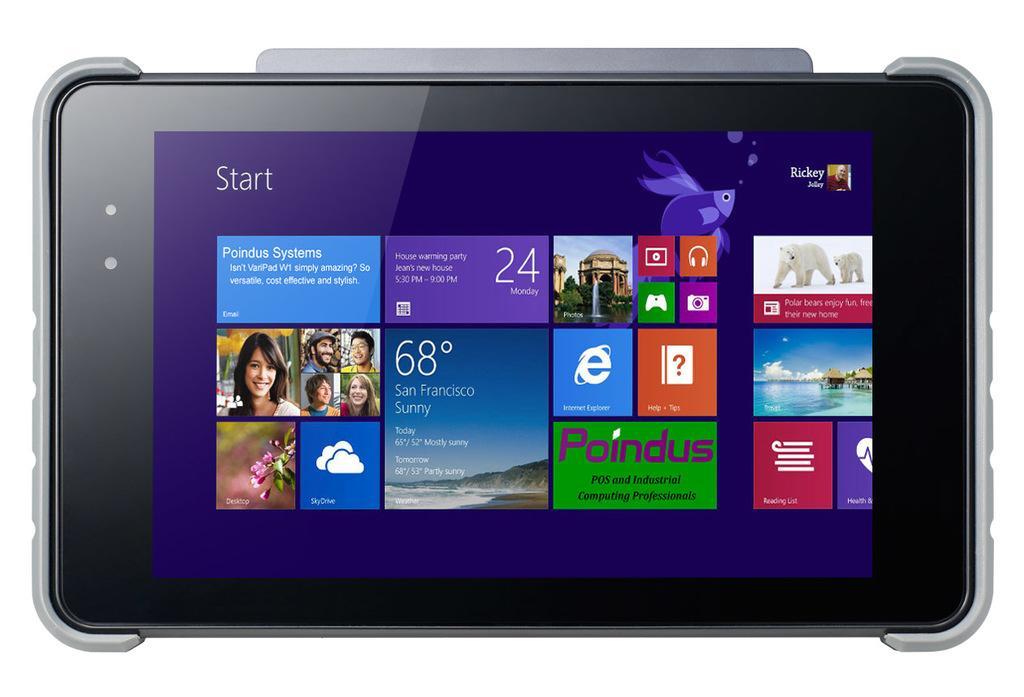How would you summarize this image in a sentence or two? In this image there is a screen and on the screen there are images and there are texts and numbers. 